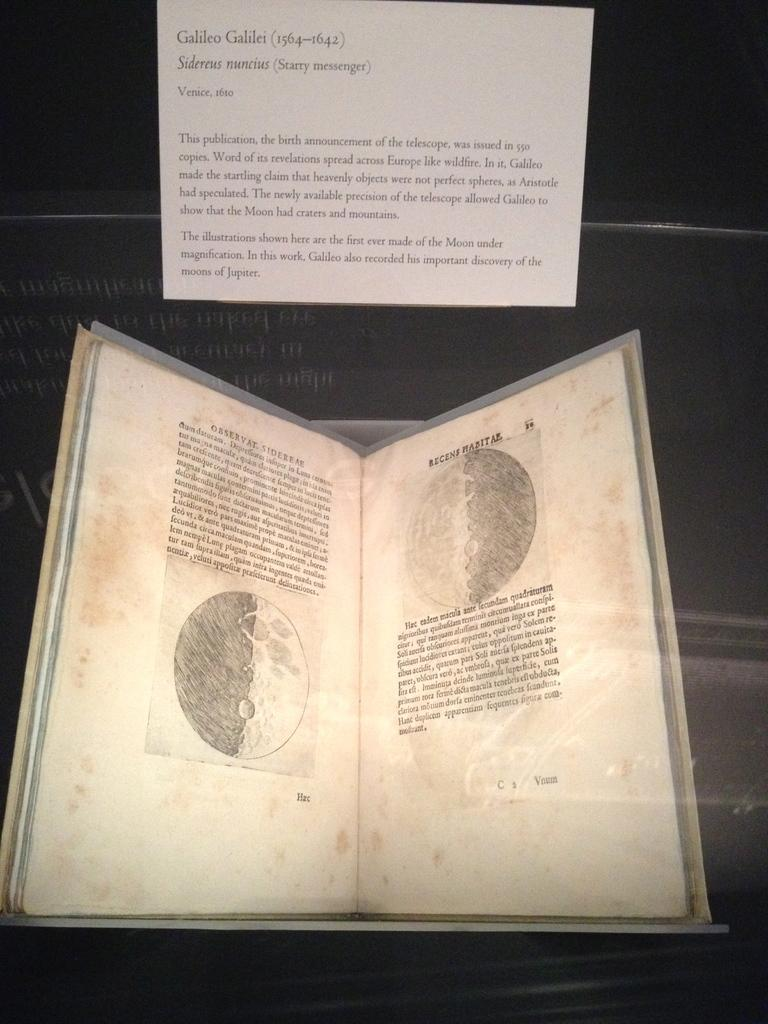<image>
Summarize the visual content of the image. A book is open to a page dealing with The Golden Mean, The Golden Section, The Golden Rectangle, and The Golden Spiral., and 